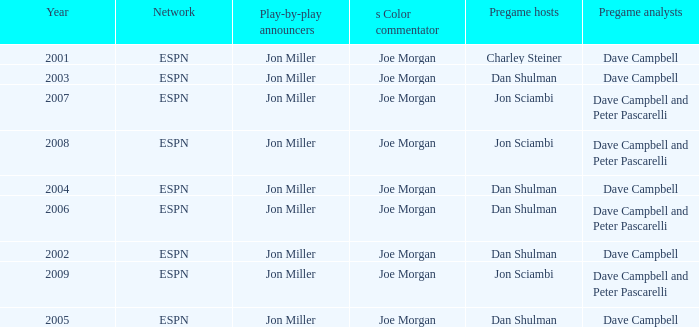Who is the pregame host when the pregame analysts is  Dave Campbell and the year is 2001? Charley Steiner. Can you give me this table as a dict? {'header': ['Year', 'Network', 'Play-by-play announcers', 's Color commentator', 'Pregame hosts', 'Pregame analysts'], 'rows': [['2001', 'ESPN', 'Jon Miller', 'Joe Morgan', 'Charley Steiner', 'Dave Campbell'], ['2003', 'ESPN', 'Jon Miller', 'Joe Morgan', 'Dan Shulman', 'Dave Campbell'], ['2007', 'ESPN', 'Jon Miller', 'Joe Morgan', 'Jon Sciambi', 'Dave Campbell and Peter Pascarelli'], ['2008', 'ESPN', 'Jon Miller', 'Joe Morgan', 'Jon Sciambi', 'Dave Campbell and Peter Pascarelli'], ['2004', 'ESPN', 'Jon Miller', 'Joe Morgan', 'Dan Shulman', 'Dave Campbell'], ['2006', 'ESPN', 'Jon Miller', 'Joe Morgan', 'Dan Shulman', 'Dave Campbell and Peter Pascarelli'], ['2002', 'ESPN', 'Jon Miller', 'Joe Morgan', 'Dan Shulman', 'Dave Campbell'], ['2009', 'ESPN', 'Jon Miller', 'Joe Morgan', 'Jon Sciambi', 'Dave Campbell and Peter Pascarelli'], ['2005', 'ESPN', 'Jon Miller', 'Joe Morgan', 'Dan Shulman', 'Dave Campbell']]} 